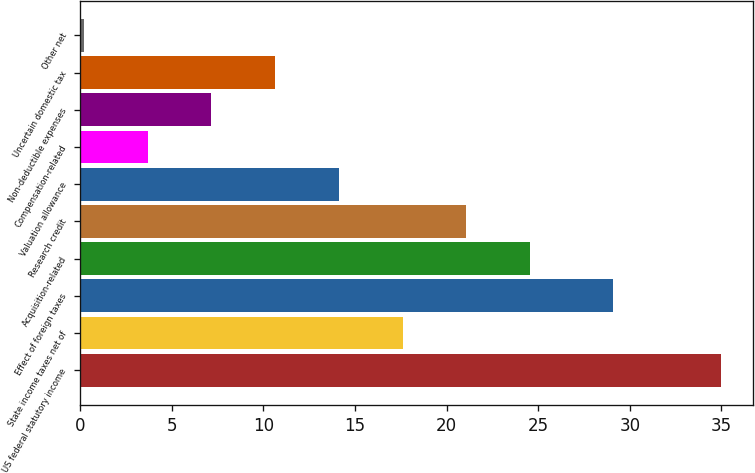<chart> <loc_0><loc_0><loc_500><loc_500><bar_chart><fcel>US federal statutory income<fcel>State income taxes net of<fcel>Effect of foreign taxes<fcel>Acquisition-related<fcel>Research credit<fcel>Valuation allowance<fcel>Compensation-related<fcel>Non-deductible expenses<fcel>Uncertain domestic tax<fcel>Other net<nl><fcel>35<fcel>17.6<fcel>29.1<fcel>24.56<fcel>21.08<fcel>14.12<fcel>3.68<fcel>7.16<fcel>10.64<fcel>0.2<nl></chart> 